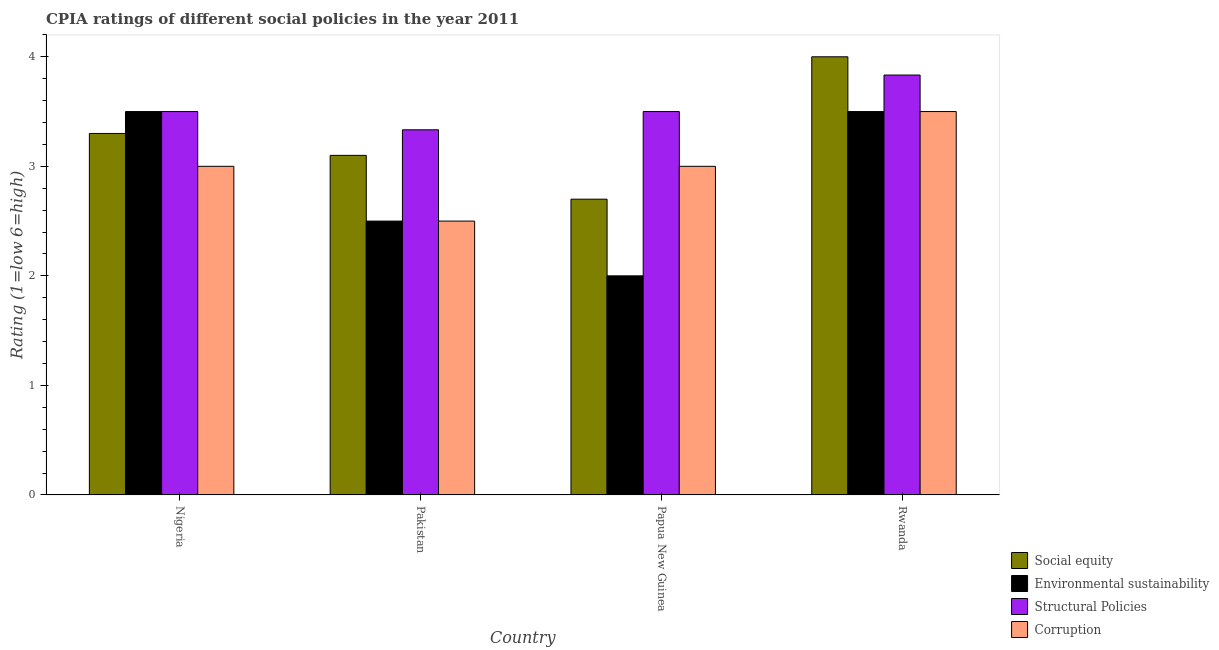How many groups of bars are there?
Provide a succinct answer. 4. Are the number of bars per tick equal to the number of legend labels?
Offer a very short reply. Yes. Are the number of bars on each tick of the X-axis equal?
Make the answer very short. Yes. How many bars are there on the 2nd tick from the left?
Ensure brevity in your answer.  4. How many bars are there on the 1st tick from the right?
Make the answer very short. 4. What is the label of the 3rd group of bars from the left?
Provide a short and direct response. Papua New Guinea. In how many cases, is the number of bars for a given country not equal to the number of legend labels?
Your answer should be very brief. 0. What is the cpia rating of social equity in Rwanda?
Your answer should be compact. 4. Across all countries, what is the maximum cpia rating of structural policies?
Make the answer very short. 3.83. Across all countries, what is the minimum cpia rating of social equity?
Make the answer very short. 2.7. In which country was the cpia rating of structural policies maximum?
Provide a short and direct response. Rwanda. In which country was the cpia rating of corruption minimum?
Your response must be concise. Pakistan. What is the total cpia rating of social equity in the graph?
Keep it short and to the point. 13.1. What is the difference between the cpia rating of social equity in Nigeria and that in Rwanda?
Give a very brief answer. -0.7. What is the average cpia rating of corruption per country?
Make the answer very short. 3. What is the difference between the cpia rating of corruption and cpia rating of environmental sustainability in Pakistan?
Your answer should be compact. 0. In how many countries, is the cpia rating of corruption greater than 0.6000000000000001 ?
Offer a very short reply. 4. What is the ratio of the cpia rating of structural policies in Pakistan to that in Papua New Guinea?
Ensure brevity in your answer.  0.95. Is the difference between the cpia rating of social equity in Nigeria and Pakistan greater than the difference between the cpia rating of structural policies in Nigeria and Pakistan?
Offer a very short reply. Yes. What is the difference between the highest and the second highest cpia rating of social equity?
Your response must be concise. 0.7. Is it the case that in every country, the sum of the cpia rating of structural policies and cpia rating of corruption is greater than the sum of cpia rating of social equity and cpia rating of environmental sustainability?
Your response must be concise. No. What does the 3rd bar from the left in Pakistan represents?
Your response must be concise. Structural Policies. What does the 4th bar from the right in Rwanda represents?
Ensure brevity in your answer.  Social equity. How many bars are there?
Offer a terse response. 16. Are all the bars in the graph horizontal?
Offer a terse response. No. How many countries are there in the graph?
Ensure brevity in your answer.  4. What is the difference between two consecutive major ticks on the Y-axis?
Offer a terse response. 1. Are the values on the major ticks of Y-axis written in scientific E-notation?
Your answer should be compact. No. Does the graph contain grids?
Provide a succinct answer. No. Where does the legend appear in the graph?
Provide a succinct answer. Bottom right. What is the title of the graph?
Make the answer very short. CPIA ratings of different social policies in the year 2011. What is the label or title of the X-axis?
Give a very brief answer. Country. What is the label or title of the Y-axis?
Make the answer very short. Rating (1=low 6=high). What is the Rating (1=low 6=high) in Structural Policies in Nigeria?
Your answer should be compact. 3.5. What is the Rating (1=low 6=high) in Environmental sustainability in Pakistan?
Ensure brevity in your answer.  2.5. What is the Rating (1=low 6=high) of Structural Policies in Pakistan?
Provide a short and direct response. 3.33. What is the Rating (1=low 6=high) of Environmental sustainability in Papua New Guinea?
Give a very brief answer. 2. What is the Rating (1=low 6=high) in Corruption in Papua New Guinea?
Your answer should be compact. 3. What is the Rating (1=low 6=high) in Environmental sustainability in Rwanda?
Offer a terse response. 3.5. What is the Rating (1=low 6=high) of Structural Policies in Rwanda?
Provide a short and direct response. 3.83. What is the Rating (1=low 6=high) in Corruption in Rwanda?
Your answer should be very brief. 3.5. Across all countries, what is the maximum Rating (1=low 6=high) of Social equity?
Provide a succinct answer. 4. Across all countries, what is the maximum Rating (1=low 6=high) in Structural Policies?
Offer a terse response. 3.83. Across all countries, what is the minimum Rating (1=low 6=high) of Social equity?
Give a very brief answer. 2.7. Across all countries, what is the minimum Rating (1=low 6=high) of Structural Policies?
Your answer should be compact. 3.33. Across all countries, what is the minimum Rating (1=low 6=high) of Corruption?
Give a very brief answer. 2.5. What is the total Rating (1=low 6=high) of Structural Policies in the graph?
Provide a short and direct response. 14.17. What is the total Rating (1=low 6=high) of Corruption in the graph?
Your response must be concise. 12. What is the difference between the Rating (1=low 6=high) of Social equity in Nigeria and that in Pakistan?
Ensure brevity in your answer.  0.2. What is the difference between the Rating (1=low 6=high) of Structural Policies in Nigeria and that in Pakistan?
Your answer should be very brief. 0.17. What is the difference between the Rating (1=low 6=high) of Environmental sustainability in Nigeria and that in Papua New Guinea?
Provide a short and direct response. 1.5. What is the difference between the Rating (1=low 6=high) of Structural Policies in Nigeria and that in Papua New Guinea?
Keep it short and to the point. 0. What is the difference between the Rating (1=low 6=high) of Corruption in Nigeria and that in Papua New Guinea?
Your response must be concise. 0. What is the difference between the Rating (1=low 6=high) in Structural Policies in Nigeria and that in Rwanda?
Your response must be concise. -0.33. What is the difference between the Rating (1=low 6=high) in Corruption in Nigeria and that in Rwanda?
Your answer should be very brief. -0.5. What is the difference between the Rating (1=low 6=high) in Environmental sustainability in Pakistan and that in Papua New Guinea?
Your response must be concise. 0.5. What is the difference between the Rating (1=low 6=high) in Corruption in Pakistan and that in Papua New Guinea?
Keep it short and to the point. -0.5. What is the difference between the Rating (1=low 6=high) in Corruption in Pakistan and that in Rwanda?
Provide a short and direct response. -1. What is the difference between the Rating (1=low 6=high) of Social equity in Papua New Guinea and that in Rwanda?
Ensure brevity in your answer.  -1.3. What is the difference between the Rating (1=low 6=high) in Environmental sustainability in Papua New Guinea and that in Rwanda?
Your answer should be very brief. -1.5. What is the difference between the Rating (1=low 6=high) of Corruption in Papua New Guinea and that in Rwanda?
Provide a short and direct response. -0.5. What is the difference between the Rating (1=low 6=high) of Social equity in Nigeria and the Rating (1=low 6=high) of Structural Policies in Pakistan?
Offer a terse response. -0.03. What is the difference between the Rating (1=low 6=high) in Social equity in Nigeria and the Rating (1=low 6=high) in Corruption in Pakistan?
Give a very brief answer. 0.8. What is the difference between the Rating (1=low 6=high) in Structural Policies in Nigeria and the Rating (1=low 6=high) in Corruption in Pakistan?
Provide a short and direct response. 1. What is the difference between the Rating (1=low 6=high) of Social equity in Nigeria and the Rating (1=low 6=high) of Environmental sustainability in Papua New Guinea?
Offer a very short reply. 1.3. What is the difference between the Rating (1=low 6=high) of Social equity in Nigeria and the Rating (1=low 6=high) of Structural Policies in Papua New Guinea?
Provide a short and direct response. -0.2. What is the difference between the Rating (1=low 6=high) of Structural Policies in Nigeria and the Rating (1=low 6=high) of Corruption in Papua New Guinea?
Provide a succinct answer. 0.5. What is the difference between the Rating (1=low 6=high) in Social equity in Nigeria and the Rating (1=low 6=high) in Structural Policies in Rwanda?
Provide a succinct answer. -0.53. What is the difference between the Rating (1=low 6=high) of Social equity in Nigeria and the Rating (1=low 6=high) of Corruption in Rwanda?
Your answer should be very brief. -0.2. What is the difference between the Rating (1=low 6=high) in Environmental sustainability in Nigeria and the Rating (1=low 6=high) in Structural Policies in Rwanda?
Provide a succinct answer. -0.33. What is the difference between the Rating (1=low 6=high) in Environmental sustainability in Nigeria and the Rating (1=low 6=high) in Corruption in Rwanda?
Make the answer very short. 0. What is the difference between the Rating (1=low 6=high) in Structural Policies in Nigeria and the Rating (1=low 6=high) in Corruption in Rwanda?
Ensure brevity in your answer.  0. What is the difference between the Rating (1=low 6=high) in Social equity in Pakistan and the Rating (1=low 6=high) in Environmental sustainability in Papua New Guinea?
Your response must be concise. 1.1. What is the difference between the Rating (1=low 6=high) in Social equity in Pakistan and the Rating (1=low 6=high) in Structural Policies in Papua New Guinea?
Your answer should be compact. -0.4. What is the difference between the Rating (1=low 6=high) in Environmental sustainability in Pakistan and the Rating (1=low 6=high) in Structural Policies in Papua New Guinea?
Make the answer very short. -1. What is the difference between the Rating (1=low 6=high) in Environmental sustainability in Pakistan and the Rating (1=low 6=high) in Corruption in Papua New Guinea?
Your response must be concise. -0.5. What is the difference between the Rating (1=low 6=high) of Structural Policies in Pakistan and the Rating (1=low 6=high) of Corruption in Papua New Guinea?
Keep it short and to the point. 0.33. What is the difference between the Rating (1=low 6=high) of Social equity in Pakistan and the Rating (1=low 6=high) of Environmental sustainability in Rwanda?
Make the answer very short. -0.4. What is the difference between the Rating (1=low 6=high) in Social equity in Pakistan and the Rating (1=low 6=high) in Structural Policies in Rwanda?
Provide a succinct answer. -0.73. What is the difference between the Rating (1=low 6=high) in Environmental sustainability in Pakistan and the Rating (1=low 6=high) in Structural Policies in Rwanda?
Offer a terse response. -1.33. What is the difference between the Rating (1=low 6=high) of Environmental sustainability in Pakistan and the Rating (1=low 6=high) of Corruption in Rwanda?
Make the answer very short. -1. What is the difference between the Rating (1=low 6=high) of Social equity in Papua New Guinea and the Rating (1=low 6=high) of Structural Policies in Rwanda?
Keep it short and to the point. -1.13. What is the difference between the Rating (1=low 6=high) of Environmental sustainability in Papua New Guinea and the Rating (1=low 6=high) of Structural Policies in Rwanda?
Provide a short and direct response. -1.83. What is the difference between the Rating (1=low 6=high) in Environmental sustainability in Papua New Guinea and the Rating (1=low 6=high) in Corruption in Rwanda?
Make the answer very short. -1.5. What is the difference between the Rating (1=low 6=high) in Structural Policies in Papua New Guinea and the Rating (1=low 6=high) in Corruption in Rwanda?
Offer a very short reply. 0. What is the average Rating (1=low 6=high) in Social equity per country?
Offer a terse response. 3.27. What is the average Rating (1=low 6=high) in Environmental sustainability per country?
Keep it short and to the point. 2.88. What is the average Rating (1=low 6=high) of Structural Policies per country?
Provide a short and direct response. 3.54. What is the average Rating (1=low 6=high) in Corruption per country?
Your answer should be compact. 3. What is the difference between the Rating (1=low 6=high) in Social equity and Rating (1=low 6=high) in Environmental sustainability in Nigeria?
Your answer should be very brief. -0.2. What is the difference between the Rating (1=low 6=high) of Social equity and Rating (1=low 6=high) of Corruption in Nigeria?
Give a very brief answer. 0.3. What is the difference between the Rating (1=low 6=high) of Environmental sustainability and Rating (1=low 6=high) of Structural Policies in Nigeria?
Make the answer very short. 0. What is the difference between the Rating (1=low 6=high) of Structural Policies and Rating (1=low 6=high) of Corruption in Nigeria?
Your response must be concise. 0.5. What is the difference between the Rating (1=low 6=high) in Social equity and Rating (1=low 6=high) in Structural Policies in Pakistan?
Give a very brief answer. -0.23. What is the difference between the Rating (1=low 6=high) in Social equity and Rating (1=low 6=high) in Corruption in Pakistan?
Offer a terse response. 0.6. What is the difference between the Rating (1=low 6=high) of Environmental sustainability and Rating (1=low 6=high) of Structural Policies in Pakistan?
Make the answer very short. -0.83. What is the difference between the Rating (1=low 6=high) in Structural Policies and Rating (1=low 6=high) in Corruption in Pakistan?
Offer a terse response. 0.83. What is the difference between the Rating (1=low 6=high) of Environmental sustainability and Rating (1=low 6=high) of Corruption in Papua New Guinea?
Keep it short and to the point. -1. What is the difference between the Rating (1=low 6=high) of Social equity and Rating (1=low 6=high) of Environmental sustainability in Rwanda?
Your response must be concise. 0.5. What is the difference between the Rating (1=low 6=high) of Social equity and Rating (1=low 6=high) of Structural Policies in Rwanda?
Your answer should be compact. 0.17. What is the difference between the Rating (1=low 6=high) of Social equity and Rating (1=low 6=high) of Corruption in Rwanda?
Your answer should be compact. 0.5. What is the difference between the Rating (1=low 6=high) in Environmental sustainability and Rating (1=low 6=high) in Structural Policies in Rwanda?
Keep it short and to the point. -0.33. What is the difference between the Rating (1=low 6=high) in Environmental sustainability and Rating (1=low 6=high) in Corruption in Rwanda?
Keep it short and to the point. 0. What is the ratio of the Rating (1=low 6=high) of Social equity in Nigeria to that in Pakistan?
Your answer should be compact. 1.06. What is the ratio of the Rating (1=low 6=high) in Structural Policies in Nigeria to that in Pakistan?
Make the answer very short. 1.05. What is the ratio of the Rating (1=low 6=high) of Corruption in Nigeria to that in Pakistan?
Provide a short and direct response. 1.2. What is the ratio of the Rating (1=low 6=high) in Social equity in Nigeria to that in Papua New Guinea?
Keep it short and to the point. 1.22. What is the ratio of the Rating (1=low 6=high) in Environmental sustainability in Nigeria to that in Papua New Guinea?
Give a very brief answer. 1.75. What is the ratio of the Rating (1=low 6=high) of Structural Policies in Nigeria to that in Papua New Guinea?
Provide a short and direct response. 1. What is the ratio of the Rating (1=low 6=high) in Social equity in Nigeria to that in Rwanda?
Your answer should be very brief. 0.82. What is the ratio of the Rating (1=low 6=high) in Environmental sustainability in Nigeria to that in Rwanda?
Your response must be concise. 1. What is the ratio of the Rating (1=low 6=high) in Social equity in Pakistan to that in Papua New Guinea?
Make the answer very short. 1.15. What is the ratio of the Rating (1=low 6=high) in Environmental sustainability in Pakistan to that in Papua New Guinea?
Keep it short and to the point. 1.25. What is the ratio of the Rating (1=low 6=high) in Corruption in Pakistan to that in Papua New Guinea?
Offer a very short reply. 0.83. What is the ratio of the Rating (1=low 6=high) of Social equity in Pakistan to that in Rwanda?
Give a very brief answer. 0.78. What is the ratio of the Rating (1=low 6=high) of Environmental sustainability in Pakistan to that in Rwanda?
Ensure brevity in your answer.  0.71. What is the ratio of the Rating (1=low 6=high) in Structural Policies in Pakistan to that in Rwanda?
Your response must be concise. 0.87. What is the ratio of the Rating (1=low 6=high) of Corruption in Pakistan to that in Rwanda?
Make the answer very short. 0.71. What is the ratio of the Rating (1=low 6=high) of Social equity in Papua New Guinea to that in Rwanda?
Ensure brevity in your answer.  0.68. What is the difference between the highest and the second highest Rating (1=low 6=high) of Social equity?
Offer a very short reply. 0.7. What is the difference between the highest and the second highest Rating (1=low 6=high) in Environmental sustainability?
Make the answer very short. 0. What is the difference between the highest and the second highest Rating (1=low 6=high) of Structural Policies?
Ensure brevity in your answer.  0.33. What is the difference between the highest and the second highest Rating (1=low 6=high) of Corruption?
Offer a very short reply. 0.5. What is the difference between the highest and the lowest Rating (1=low 6=high) in Social equity?
Keep it short and to the point. 1.3. What is the difference between the highest and the lowest Rating (1=low 6=high) of Environmental sustainability?
Ensure brevity in your answer.  1.5. 